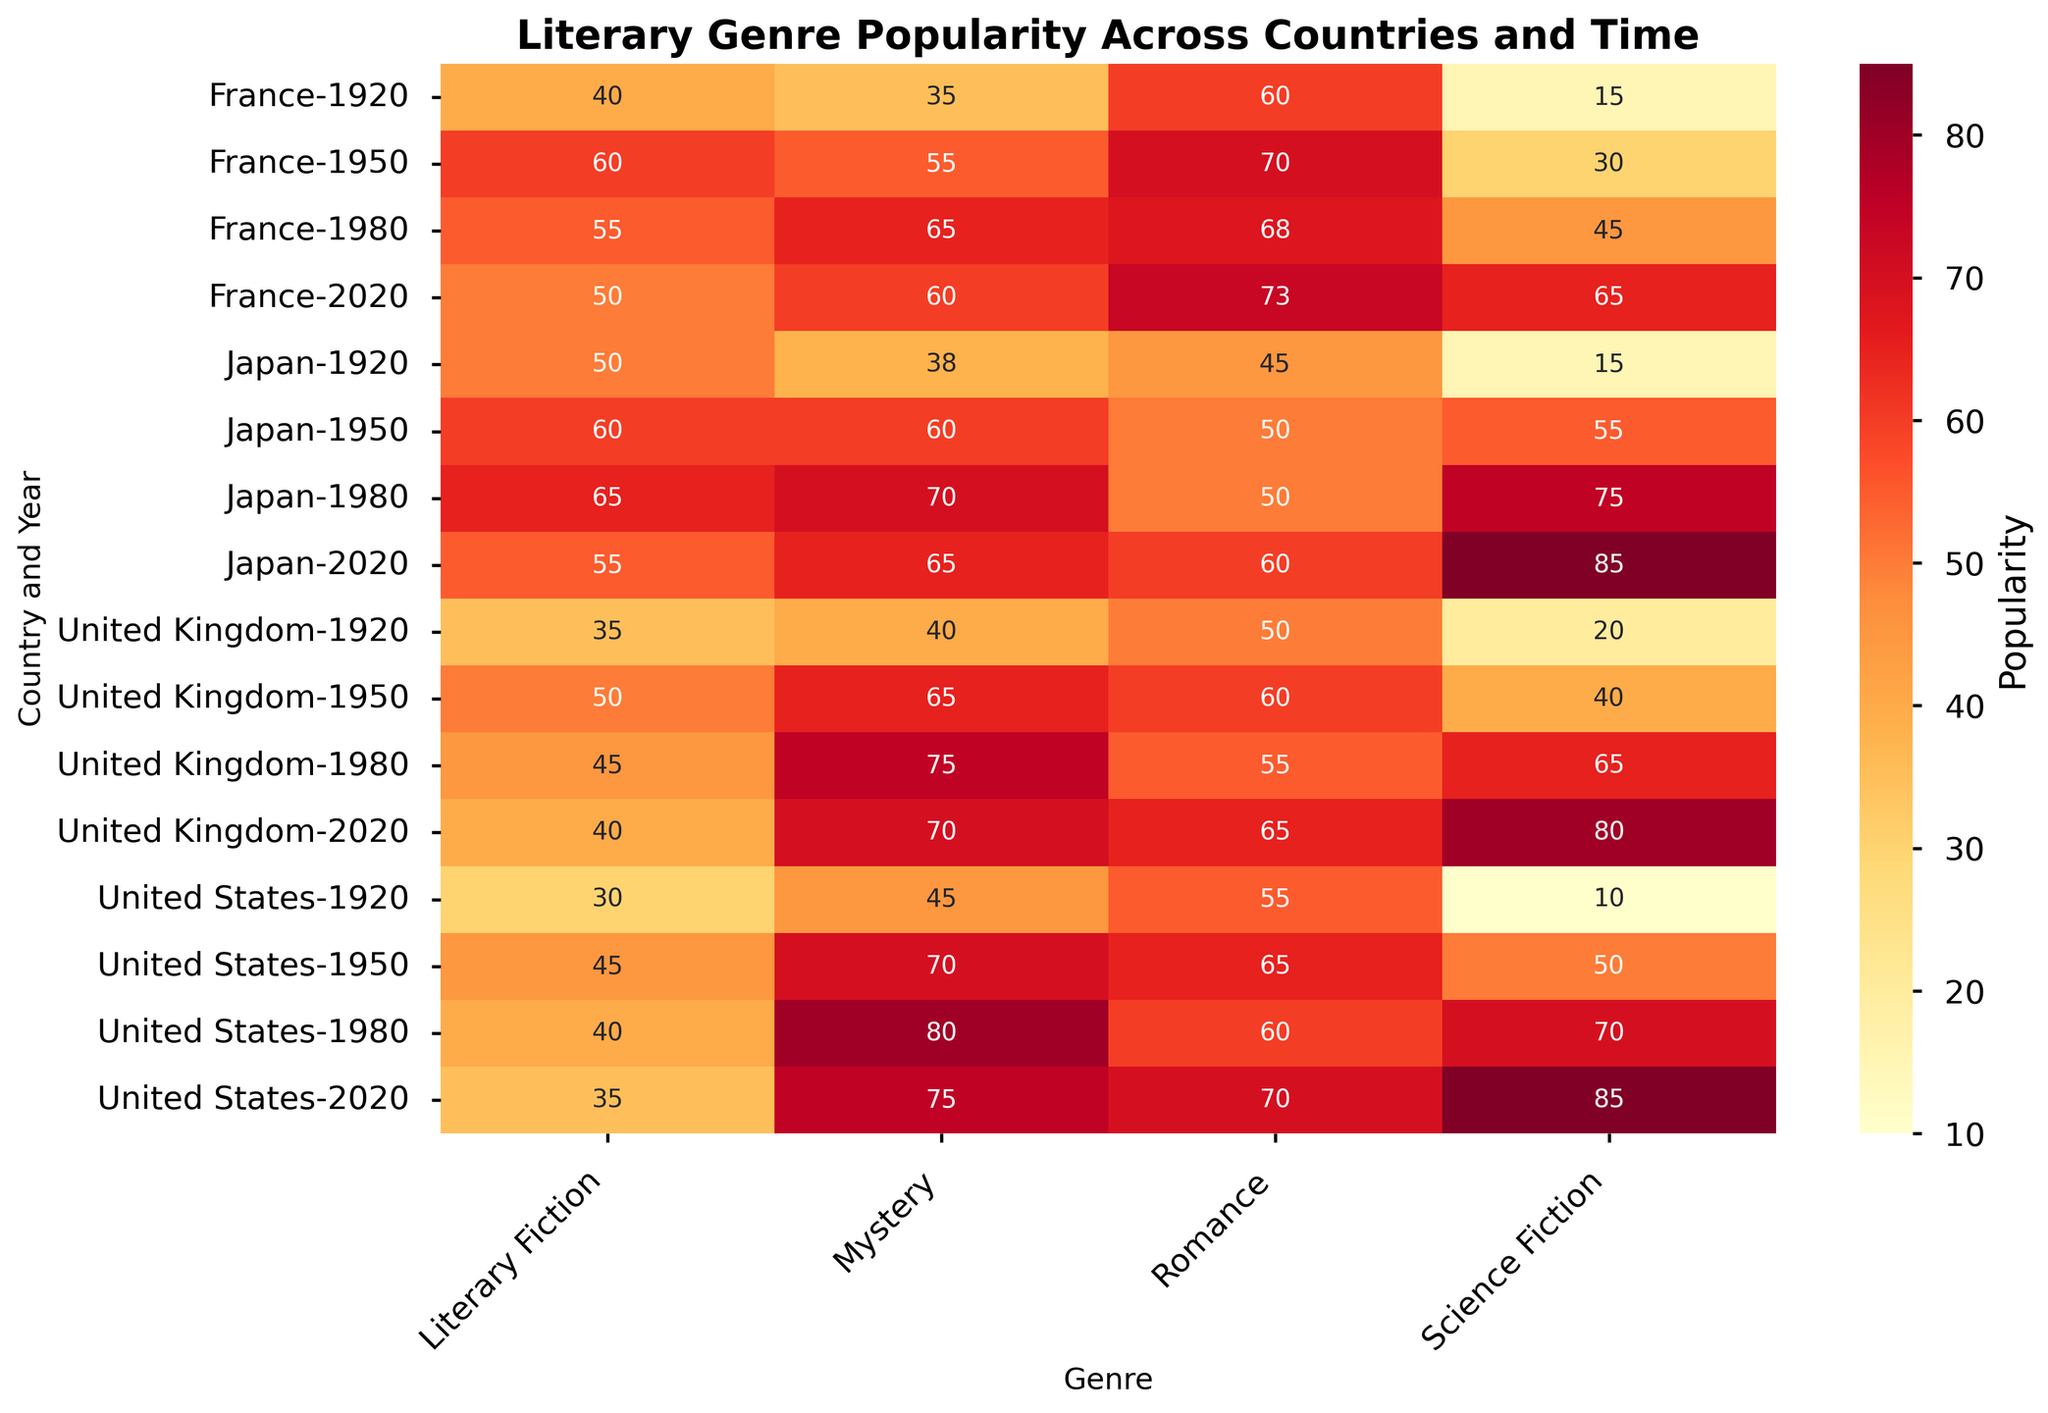Which country had the highest popularity for science fiction in 2020? Look for the country and year corresponding to 2020 for science fiction and find the highest number.
Answer: United States What is the average popularity of literary fiction in Japan across all years? Extract the popularity values for Japan under literary fiction across all years (1920, 1950, 1980, 2020), and calculate the average: (50 + 60 + 65 + 55)/4 = 57.5
Answer: 57.5 Which genre in the United States saw the largest increase in popularity from 1920 to 2020? Find the difference in popularity for each genre between 1920 and 2020, then identify the genre with the largest difference: Mystery (75-45=30), Romance (70-55=15), Science Fiction (85-10=75), Literary Fiction (35-30=5). Science Fiction has the largest increase.
Answer: Science Fiction Compare the popularity of mystery genre in 1980 between United Kingdom and Japan. Which one is higher? Locate the popularity of mystery in 1980 for both United Kingdom (75) and Japan (70), compare the two values.
Answer: United Kingdom What is the total popularity of romance genre across all countries in 1950? Sum the popularity of romance in 1950 for all countries: US (65), UK (60), Japan (50), France (70). Total is 65 + 60 + 50 + 70 = 245.
Answer: 245 Which country had the least popularity for literary fiction in 1980? Identify the popularity values for literary fiction in 1980 across all countries and locate the minimum: US (40), UK (45), Japan (65), France (55). The least is US.
Answer: United States How did the popularity of romance in France change from 1920 to 2020? Calculate the difference in popularity for romance in France between 1920 and 2020: 73 - 60 = 13.
Answer: Increased by 13 Which genre in the United Kingdom had the most consistent popularity over time? Examine the popularity of all genres in the United Kingdom across the years and identify the one with the least fluctuations: Mystery (40, 65, 75, 70), Romance (50, 60, 55, 65), Science Fiction (20, 40, 65, 80), Literary Fiction (35, 50, 45, 40). Literary Fiction shows the least fluctuations.
Answer: Literary Fiction What is the median popularity of mystery genre across all years in the United States? Collect the popularity values of mystery for all years in the United States: 45, 70, 80, 75. The sorted values are 45, 70, 75, 80. Median is (70+75)/2 = 72.5
Answer: 72.5 